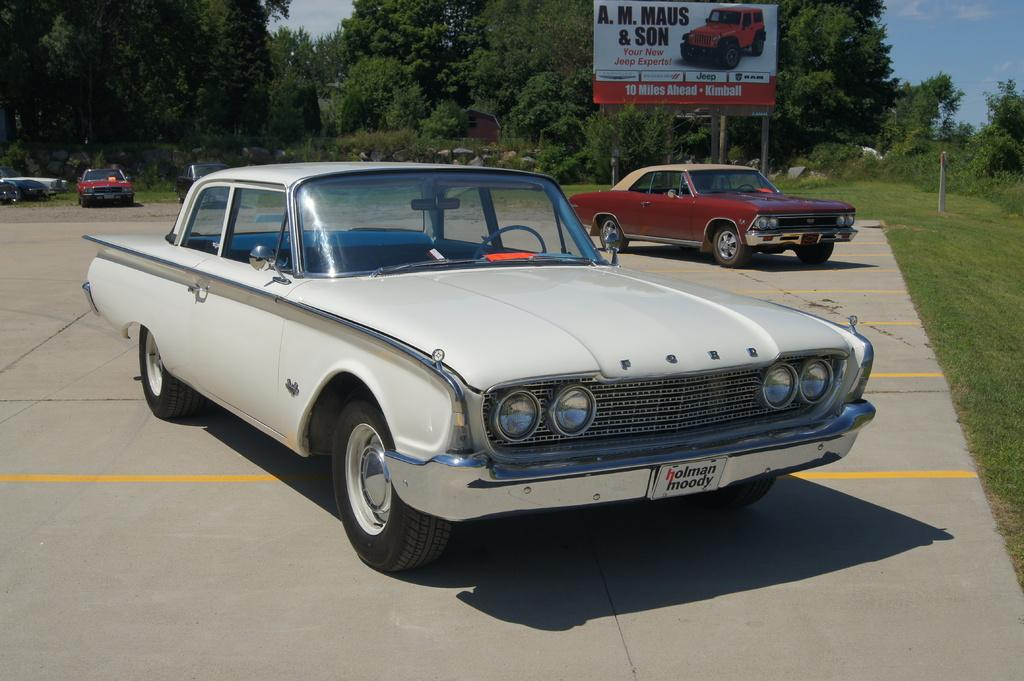What can be seen on the road in the image? There are fleets of cars on the road in the image. What type of vegetation is visible in the image? There is grass visible in the image. What structures can be seen in the background of the image? There is a fence, a board, and trees in the background of the image. What part of the natural environment is visible in the image? The sky is visible in the background of the image. What channel is the passenger attempting to change on the board in the image? There is no board with a channel or passenger present in the image. 